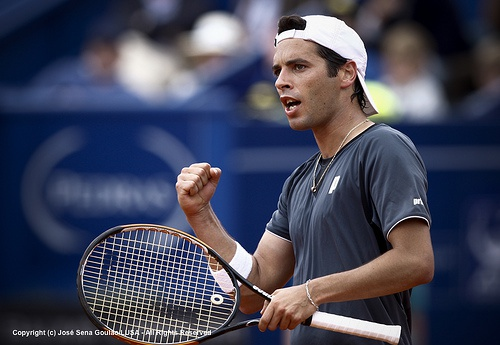Describe the objects in this image and their specific colors. I can see people in navy, black, gray, and white tones and tennis racket in navy, black, lightgray, and darkgray tones in this image. 